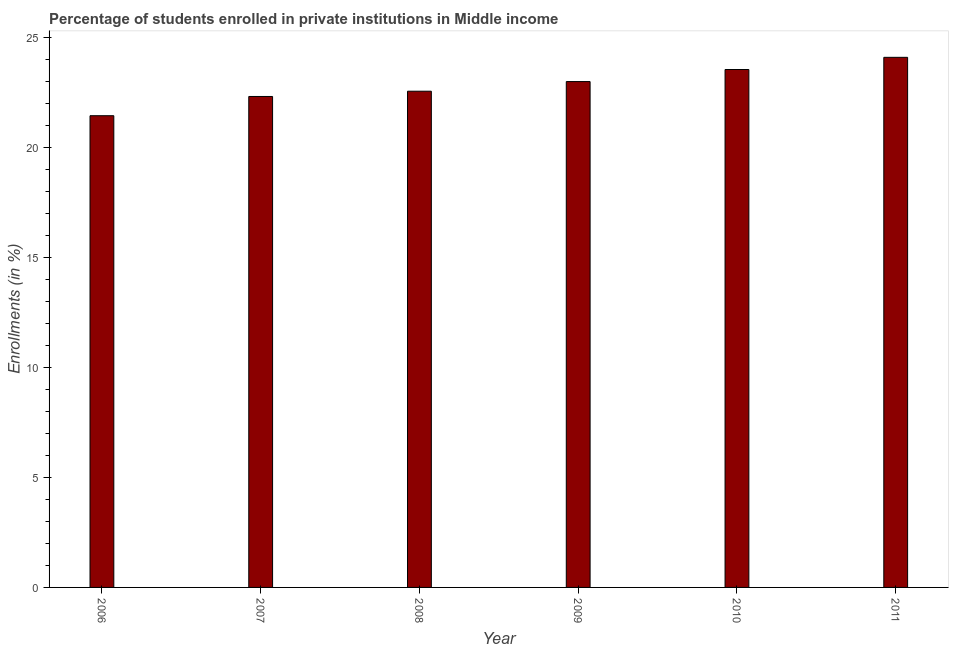What is the title of the graph?
Your answer should be very brief. Percentage of students enrolled in private institutions in Middle income. What is the label or title of the Y-axis?
Give a very brief answer. Enrollments (in %). What is the enrollments in private institutions in 2008?
Offer a very short reply. 22.54. Across all years, what is the maximum enrollments in private institutions?
Keep it short and to the point. 24.08. Across all years, what is the minimum enrollments in private institutions?
Offer a very short reply. 21.43. In which year was the enrollments in private institutions maximum?
Offer a terse response. 2011. What is the sum of the enrollments in private institutions?
Your response must be concise. 136.84. What is the difference between the enrollments in private institutions in 2006 and 2008?
Your answer should be compact. -1.11. What is the average enrollments in private institutions per year?
Keep it short and to the point. 22.81. What is the median enrollments in private institutions?
Keep it short and to the point. 22.76. Do a majority of the years between 2008 and 2006 (inclusive) have enrollments in private institutions greater than 5 %?
Provide a short and direct response. Yes. What is the ratio of the enrollments in private institutions in 2007 to that in 2010?
Offer a very short reply. 0.95. Is the enrollments in private institutions in 2007 less than that in 2011?
Keep it short and to the point. Yes. Is the difference between the enrollments in private institutions in 2008 and 2009 greater than the difference between any two years?
Your response must be concise. No. What is the difference between the highest and the second highest enrollments in private institutions?
Provide a succinct answer. 0.55. Is the sum of the enrollments in private institutions in 2006 and 2011 greater than the maximum enrollments in private institutions across all years?
Keep it short and to the point. Yes. What is the difference between the highest and the lowest enrollments in private institutions?
Provide a succinct answer. 2.65. In how many years, is the enrollments in private institutions greater than the average enrollments in private institutions taken over all years?
Offer a terse response. 3. How many bars are there?
Ensure brevity in your answer.  6. Are all the bars in the graph horizontal?
Keep it short and to the point. No. How many years are there in the graph?
Provide a short and direct response. 6. What is the Enrollments (in %) of 2006?
Offer a very short reply. 21.43. What is the Enrollments (in %) in 2007?
Your response must be concise. 22.3. What is the Enrollments (in %) of 2008?
Make the answer very short. 22.54. What is the Enrollments (in %) in 2009?
Offer a very short reply. 22.98. What is the Enrollments (in %) in 2010?
Ensure brevity in your answer.  23.52. What is the Enrollments (in %) in 2011?
Your answer should be very brief. 24.08. What is the difference between the Enrollments (in %) in 2006 and 2007?
Keep it short and to the point. -0.87. What is the difference between the Enrollments (in %) in 2006 and 2008?
Offer a terse response. -1.11. What is the difference between the Enrollments (in %) in 2006 and 2009?
Your answer should be compact. -1.55. What is the difference between the Enrollments (in %) in 2006 and 2010?
Keep it short and to the point. -2.1. What is the difference between the Enrollments (in %) in 2006 and 2011?
Provide a short and direct response. -2.65. What is the difference between the Enrollments (in %) in 2007 and 2008?
Give a very brief answer. -0.24. What is the difference between the Enrollments (in %) in 2007 and 2009?
Ensure brevity in your answer.  -0.68. What is the difference between the Enrollments (in %) in 2007 and 2010?
Ensure brevity in your answer.  -1.23. What is the difference between the Enrollments (in %) in 2007 and 2011?
Provide a succinct answer. -1.78. What is the difference between the Enrollments (in %) in 2008 and 2009?
Offer a very short reply. -0.44. What is the difference between the Enrollments (in %) in 2008 and 2010?
Your response must be concise. -0.99. What is the difference between the Enrollments (in %) in 2008 and 2011?
Offer a very short reply. -1.54. What is the difference between the Enrollments (in %) in 2009 and 2010?
Give a very brief answer. -0.55. What is the difference between the Enrollments (in %) in 2009 and 2011?
Make the answer very short. -1.1. What is the difference between the Enrollments (in %) in 2010 and 2011?
Provide a short and direct response. -0.55. What is the ratio of the Enrollments (in %) in 2006 to that in 2008?
Your answer should be very brief. 0.95. What is the ratio of the Enrollments (in %) in 2006 to that in 2009?
Give a very brief answer. 0.93. What is the ratio of the Enrollments (in %) in 2006 to that in 2010?
Make the answer very short. 0.91. What is the ratio of the Enrollments (in %) in 2006 to that in 2011?
Offer a very short reply. 0.89. What is the ratio of the Enrollments (in %) in 2007 to that in 2010?
Offer a very short reply. 0.95. What is the ratio of the Enrollments (in %) in 2007 to that in 2011?
Provide a short and direct response. 0.93. What is the ratio of the Enrollments (in %) in 2008 to that in 2009?
Your answer should be very brief. 0.98. What is the ratio of the Enrollments (in %) in 2008 to that in 2010?
Ensure brevity in your answer.  0.96. What is the ratio of the Enrollments (in %) in 2008 to that in 2011?
Provide a succinct answer. 0.94. What is the ratio of the Enrollments (in %) in 2009 to that in 2011?
Ensure brevity in your answer.  0.95. What is the ratio of the Enrollments (in %) in 2010 to that in 2011?
Your answer should be compact. 0.98. 